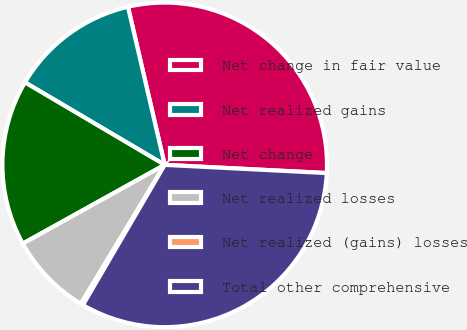<chart> <loc_0><loc_0><loc_500><loc_500><pie_chart><fcel>Net change in fair value<fcel>Net realized gains<fcel>Net change<fcel>Net realized losses<fcel>Net realized (gains) losses<fcel>Total other comprehensive<nl><fcel>29.44%<fcel>12.88%<fcel>16.55%<fcel>8.29%<fcel>0.24%<fcel>32.6%<nl></chart> 